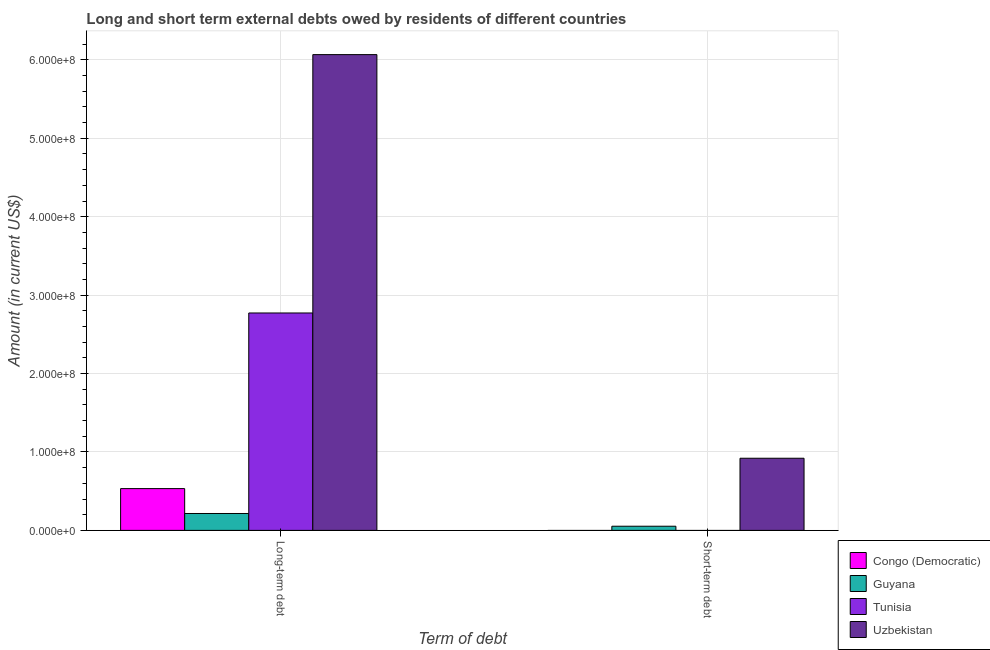How many different coloured bars are there?
Offer a terse response. 4. How many groups of bars are there?
Your answer should be compact. 2. Are the number of bars per tick equal to the number of legend labels?
Offer a terse response. No. How many bars are there on the 2nd tick from the left?
Ensure brevity in your answer.  2. How many bars are there on the 1st tick from the right?
Give a very brief answer. 2. What is the label of the 2nd group of bars from the left?
Make the answer very short. Short-term debt. What is the short-term debts owed by residents in Uzbekistan?
Provide a succinct answer. 9.20e+07. Across all countries, what is the maximum short-term debts owed by residents?
Your answer should be very brief. 9.20e+07. Across all countries, what is the minimum long-term debts owed by residents?
Your answer should be very brief. 2.15e+07. In which country was the short-term debts owed by residents maximum?
Your response must be concise. Uzbekistan. What is the total long-term debts owed by residents in the graph?
Make the answer very short. 9.59e+08. What is the difference between the long-term debts owed by residents in Uzbekistan and that in Tunisia?
Provide a succinct answer. 3.29e+08. What is the difference between the long-term debts owed by residents in Uzbekistan and the short-term debts owed by residents in Congo (Democratic)?
Offer a very short reply. 6.07e+08. What is the average short-term debts owed by residents per country?
Offer a very short reply. 2.43e+07. What is the difference between the short-term debts owed by residents and long-term debts owed by residents in Uzbekistan?
Give a very brief answer. -5.15e+08. What is the ratio of the long-term debts owed by residents in Tunisia to that in Guyana?
Your response must be concise. 12.87. How many bars are there?
Your answer should be very brief. 6. What is the difference between two consecutive major ticks on the Y-axis?
Give a very brief answer. 1.00e+08. Does the graph contain grids?
Your answer should be compact. Yes. Where does the legend appear in the graph?
Your answer should be very brief. Bottom right. How many legend labels are there?
Your answer should be compact. 4. What is the title of the graph?
Your answer should be very brief. Long and short term external debts owed by residents of different countries. Does "Cayman Islands" appear as one of the legend labels in the graph?
Make the answer very short. No. What is the label or title of the X-axis?
Offer a very short reply. Term of debt. What is the Amount (in current US$) of Congo (Democratic) in Long-term debt?
Your answer should be very brief. 5.33e+07. What is the Amount (in current US$) in Guyana in Long-term debt?
Keep it short and to the point. 2.15e+07. What is the Amount (in current US$) in Tunisia in Long-term debt?
Your answer should be very brief. 2.77e+08. What is the Amount (in current US$) of Uzbekistan in Long-term debt?
Make the answer very short. 6.07e+08. What is the Amount (in current US$) in Congo (Democratic) in Short-term debt?
Your answer should be compact. 0. What is the Amount (in current US$) in Guyana in Short-term debt?
Offer a terse response. 5.30e+06. What is the Amount (in current US$) of Tunisia in Short-term debt?
Make the answer very short. 0. What is the Amount (in current US$) of Uzbekistan in Short-term debt?
Your answer should be very brief. 9.20e+07. Across all Term of debt, what is the maximum Amount (in current US$) of Congo (Democratic)?
Keep it short and to the point. 5.33e+07. Across all Term of debt, what is the maximum Amount (in current US$) in Guyana?
Offer a very short reply. 2.15e+07. Across all Term of debt, what is the maximum Amount (in current US$) in Tunisia?
Provide a short and direct response. 2.77e+08. Across all Term of debt, what is the maximum Amount (in current US$) of Uzbekistan?
Offer a very short reply. 6.07e+08. Across all Term of debt, what is the minimum Amount (in current US$) of Congo (Democratic)?
Provide a short and direct response. 0. Across all Term of debt, what is the minimum Amount (in current US$) of Guyana?
Make the answer very short. 5.30e+06. Across all Term of debt, what is the minimum Amount (in current US$) in Uzbekistan?
Provide a succinct answer. 9.20e+07. What is the total Amount (in current US$) of Congo (Democratic) in the graph?
Your answer should be very brief. 5.33e+07. What is the total Amount (in current US$) in Guyana in the graph?
Make the answer very short. 2.68e+07. What is the total Amount (in current US$) of Tunisia in the graph?
Make the answer very short. 2.77e+08. What is the total Amount (in current US$) of Uzbekistan in the graph?
Your response must be concise. 6.99e+08. What is the difference between the Amount (in current US$) of Guyana in Long-term debt and that in Short-term debt?
Your answer should be compact. 1.62e+07. What is the difference between the Amount (in current US$) of Uzbekistan in Long-term debt and that in Short-term debt?
Keep it short and to the point. 5.15e+08. What is the difference between the Amount (in current US$) of Congo (Democratic) in Long-term debt and the Amount (in current US$) of Guyana in Short-term debt?
Give a very brief answer. 4.80e+07. What is the difference between the Amount (in current US$) in Congo (Democratic) in Long-term debt and the Amount (in current US$) in Uzbekistan in Short-term debt?
Make the answer very short. -3.87e+07. What is the difference between the Amount (in current US$) of Guyana in Long-term debt and the Amount (in current US$) of Uzbekistan in Short-term debt?
Offer a terse response. -7.05e+07. What is the difference between the Amount (in current US$) of Tunisia in Long-term debt and the Amount (in current US$) of Uzbekistan in Short-term debt?
Provide a succinct answer. 1.85e+08. What is the average Amount (in current US$) in Congo (Democratic) per Term of debt?
Offer a very short reply. 2.66e+07. What is the average Amount (in current US$) of Guyana per Term of debt?
Your answer should be very brief. 1.34e+07. What is the average Amount (in current US$) in Tunisia per Term of debt?
Ensure brevity in your answer.  1.39e+08. What is the average Amount (in current US$) of Uzbekistan per Term of debt?
Provide a short and direct response. 3.49e+08. What is the difference between the Amount (in current US$) in Congo (Democratic) and Amount (in current US$) in Guyana in Long-term debt?
Offer a very short reply. 3.17e+07. What is the difference between the Amount (in current US$) of Congo (Democratic) and Amount (in current US$) of Tunisia in Long-term debt?
Offer a terse response. -2.24e+08. What is the difference between the Amount (in current US$) of Congo (Democratic) and Amount (in current US$) of Uzbekistan in Long-term debt?
Your answer should be compact. -5.53e+08. What is the difference between the Amount (in current US$) of Guyana and Amount (in current US$) of Tunisia in Long-term debt?
Offer a very short reply. -2.56e+08. What is the difference between the Amount (in current US$) in Guyana and Amount (in current US$) in Uzbekistan in Long-term debt?
Provide a short and direct response. -5.85e+08. What is the difference between the Amount (in current US$) in Tunisia and Amount (in current US$) in Uzbekistan in Long-term debt?
Make the answer very short. -3.29e+08. What is the difference between the Amount (in current US$) of Guyana and Amount (in current US$) of Uzbekistan in Short-term debt?
Your answer should be compact. -8.67e+07. What is the ratio of the Amount (in current US$) in Guyana in Long-term debt to that in Short-term debt?
Give a very brief answer. 4.06. What is the ratio of the Amount (in current US$) in Uzbekistan in Long-term debt to that in Short-term debt?
Provide a short and direct response. 6.59. What is the difference between the highest and the second highest Amount (in current US$) of Guyana?
Your answer should be very brief. 1.62e+07. What is the difference between the highest and the second highest Amount (in current US$) in Uzbekistan?
Offer a terse response. 5.15e+08. What is the difference between the highest and the lowest Amount (in current US$) of Congo (Democratic)?
Provide a short and direct response. 5.33e+07. What is the difference between the highest and the lowest Amount (in current US$) of Guyana?
Your response must be concise. 1.62e+07. What is the difference between the highest and the lowest Amount (in current US$) in Tunisia?
Offer a very short reply. 2.77e+08. What is the difference between the highest and the lowest Amount (in current US$) in Uzbekistan?
Offer a terse response. 5.15e+08. 